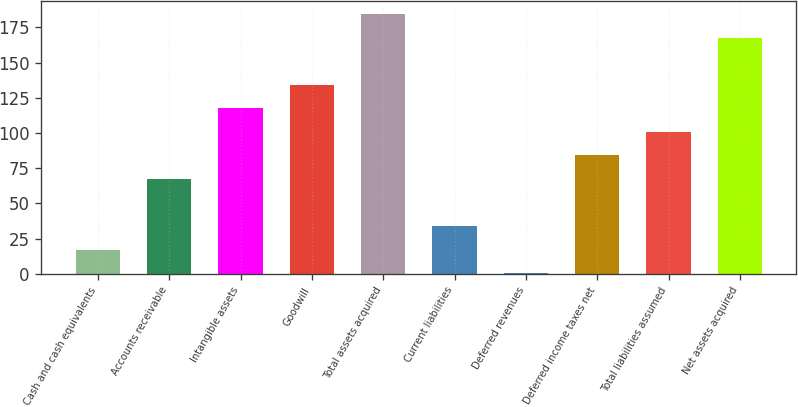<chart> <loc_0><loc_0><loc_500><loc_500><bar_chart><fcel>Cash and cash equivalents<fcel>Accounts receivable<fcel>Intangible assets<fcel>Goodwill<fcel>Total assets acquired<fcel>Current liabilities<fcel>Deferred revenues<fcel>Deferred income taxes net<fcel>Total liabilities assumed<fcel>Net assets acquired<nl><fcel>17.04<fcel>67.26<fcel>117.48<fcel>134.22<fcel>184.44<fcel>33.78<fcel>0.3<fcel>84<fcel>100.74<fcel>167.7<nl></chart> 